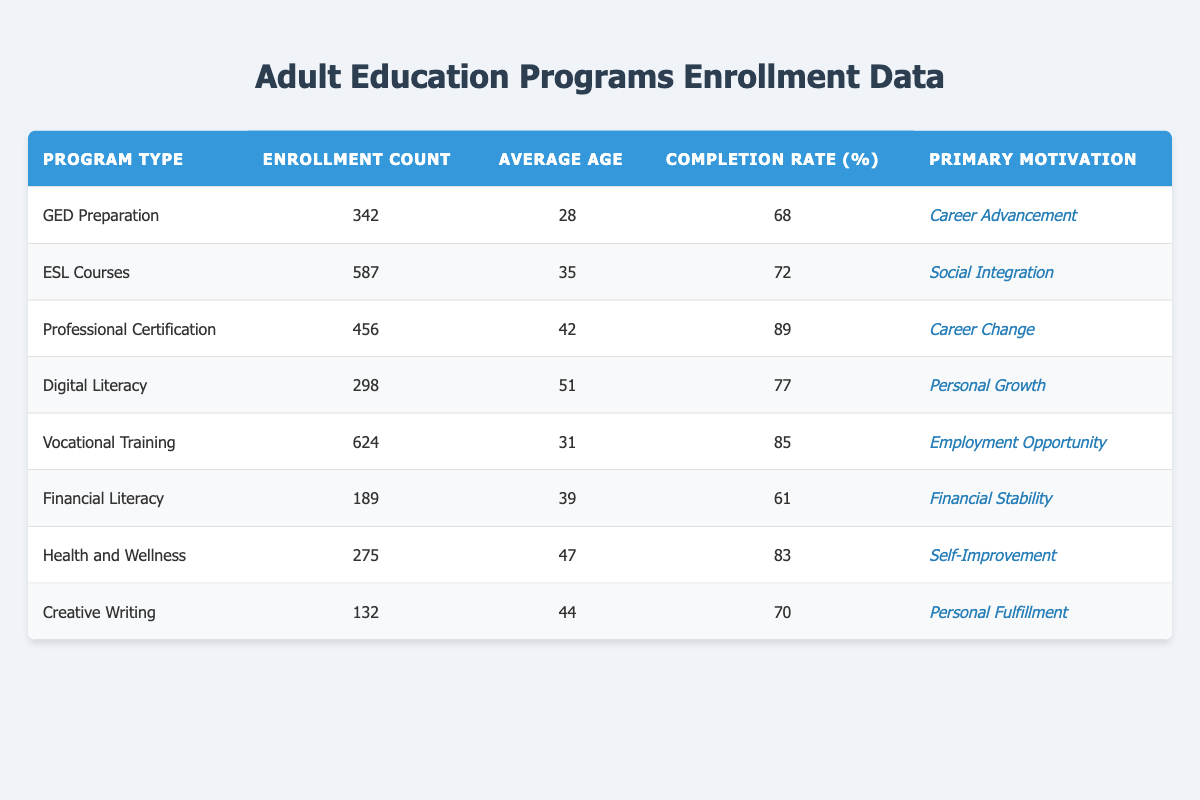What is the enrollment count for ESL Courses? The enrollment count for ESL Courses is listed directly in the table under the "Enrollment Count" column for that program type. It shows 587.
Answer: 587 Which program type has the highest completion rate? To find the highest completion rate, we compare the values in the "Completion Rate (%)" column. The highest value is 89%, which corresponds to "Professional Certification."
Answer: Professional Certification What is the average age of participants in Vocational Training? The average age for participants in Vocational Training is displayed in the table in the "Average Age" column. It indicates an average age of 31.
Answer: 31 Which program has the primary motivation of "Financial Stability"? The program with "Financial Stability" as the primary motivation is found by looking at the "Primary Motivation" column. The corresponding row indicates that "Financial Literacy" has this motivation.
Answer: Financial Literacy Calculate the average age of all the programs listed. To calculate the average age, we sum up the average ages from each program type: (28 + 35 + 42 + 51 + 31 + 39 + 47 + 44) = 317. There are 8 programs, so the average age is 317/8 = 39.625, which can be rounded to 40.
Answer: 40 Is the completion rate for Digital Literacy higher than that for Financial Literacy? We compare the completion rates for both programs: Digital Literacy has a completion rate of 77%, while Financial Literacy has 61%. Since 77% is greater than 61%, the statement is true.
Answer: Yes Which program type has the lowest enrollment count? By examining the "Enrollment Count" column, we identify the lowest number. The smallest value is 132, which belongs to the "Creative Writing" program type.
Answer: Creative Writing What is the overall completion rate for programs with a primary motivation of "Career Change"? The only program with "Career Change" as the primary motivation is "Professional Certification," which has a completion rate of 89%. Since there is only one program, the overall completion rate is the same as that program's rate.
Answer: 89 How many programs have an average age greater than 40? We examine the "Average Age" column to identify programs over 40 years. The programs are: Digital Literacy (51), Professional Certification (42), and Health and Wellness (47). This gives us a total of 3 programs.
Answer: 3 